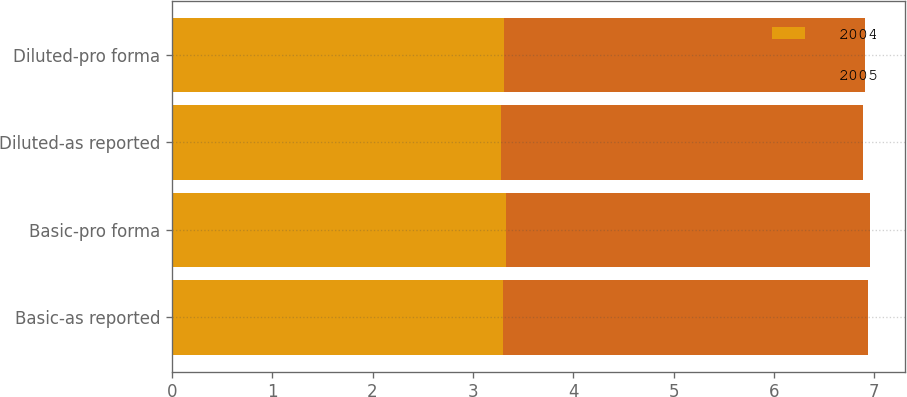Convert chart. <chart><loc_0><loc_0><loc_500><loc_500><stacked_bar_chart><ecel><fcel>Basic-as reported<fcel>Basic-pro forma<fcel>Diluted-as reported<fcel>Diluted-pro forma<nl><fcel>2004<fcel>3.3<fcel>3.33<fcel>3.28<fcel>3.31<nl><fcel>2005<fcel>3.64<fcel>3.63<fcel>3.61<fcel>3.6<nl></chart> 